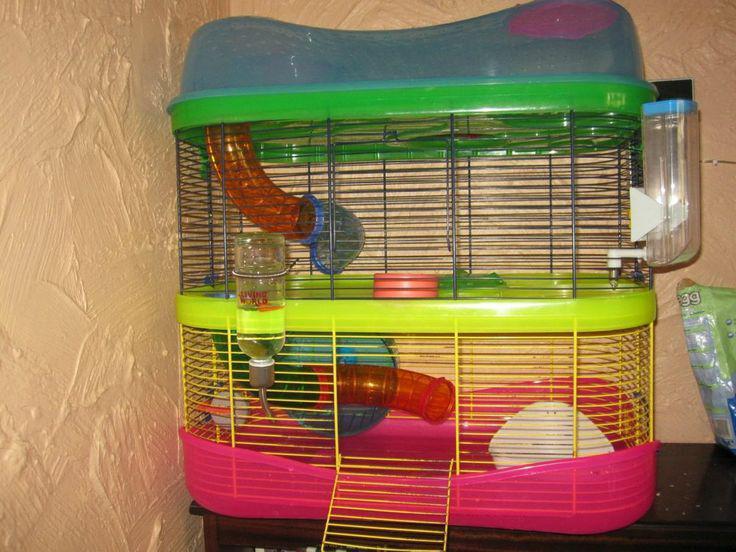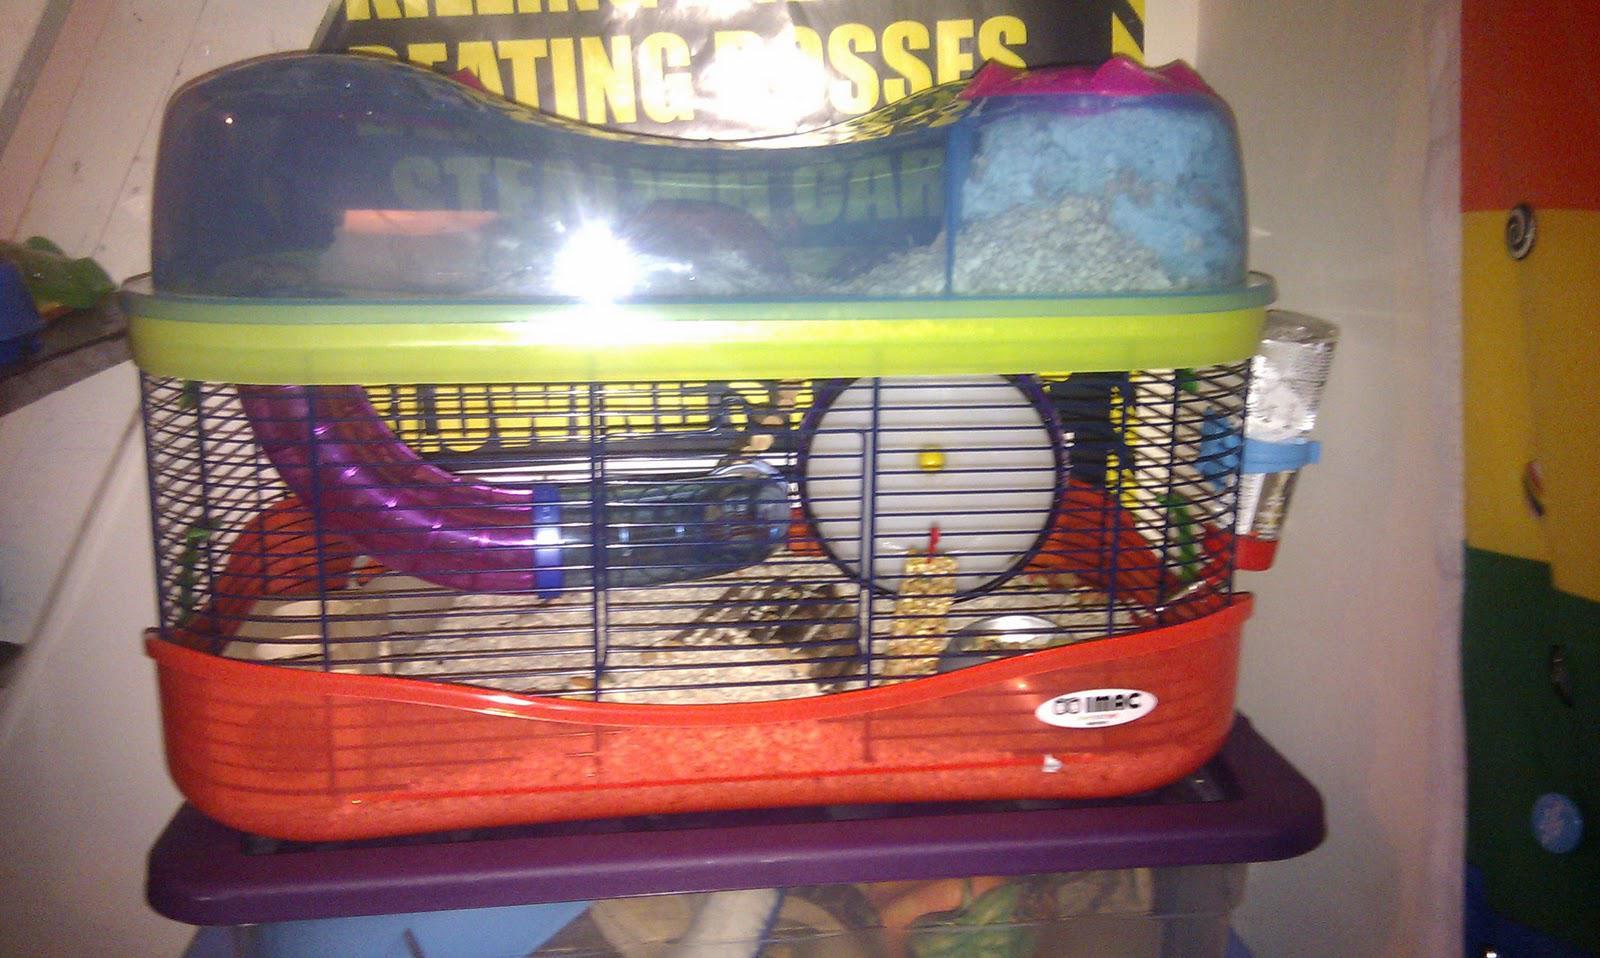The first image is the image on the left, the second image is the image on the right. Analyze the images presented: Is the assertion "Both hamster cages have 2 stories." valid? Answer yes or no. No. 